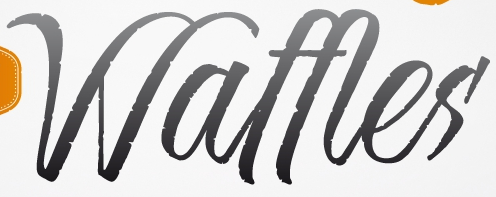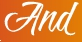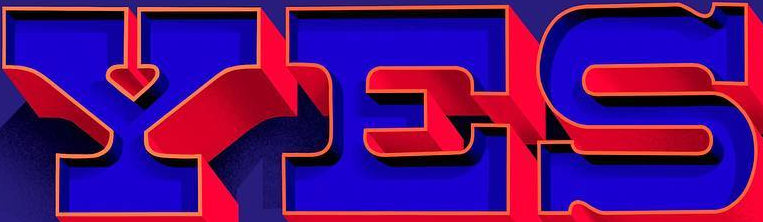Read the text from these images in sequence, separated by a semicolon. Waffles; And; YES 